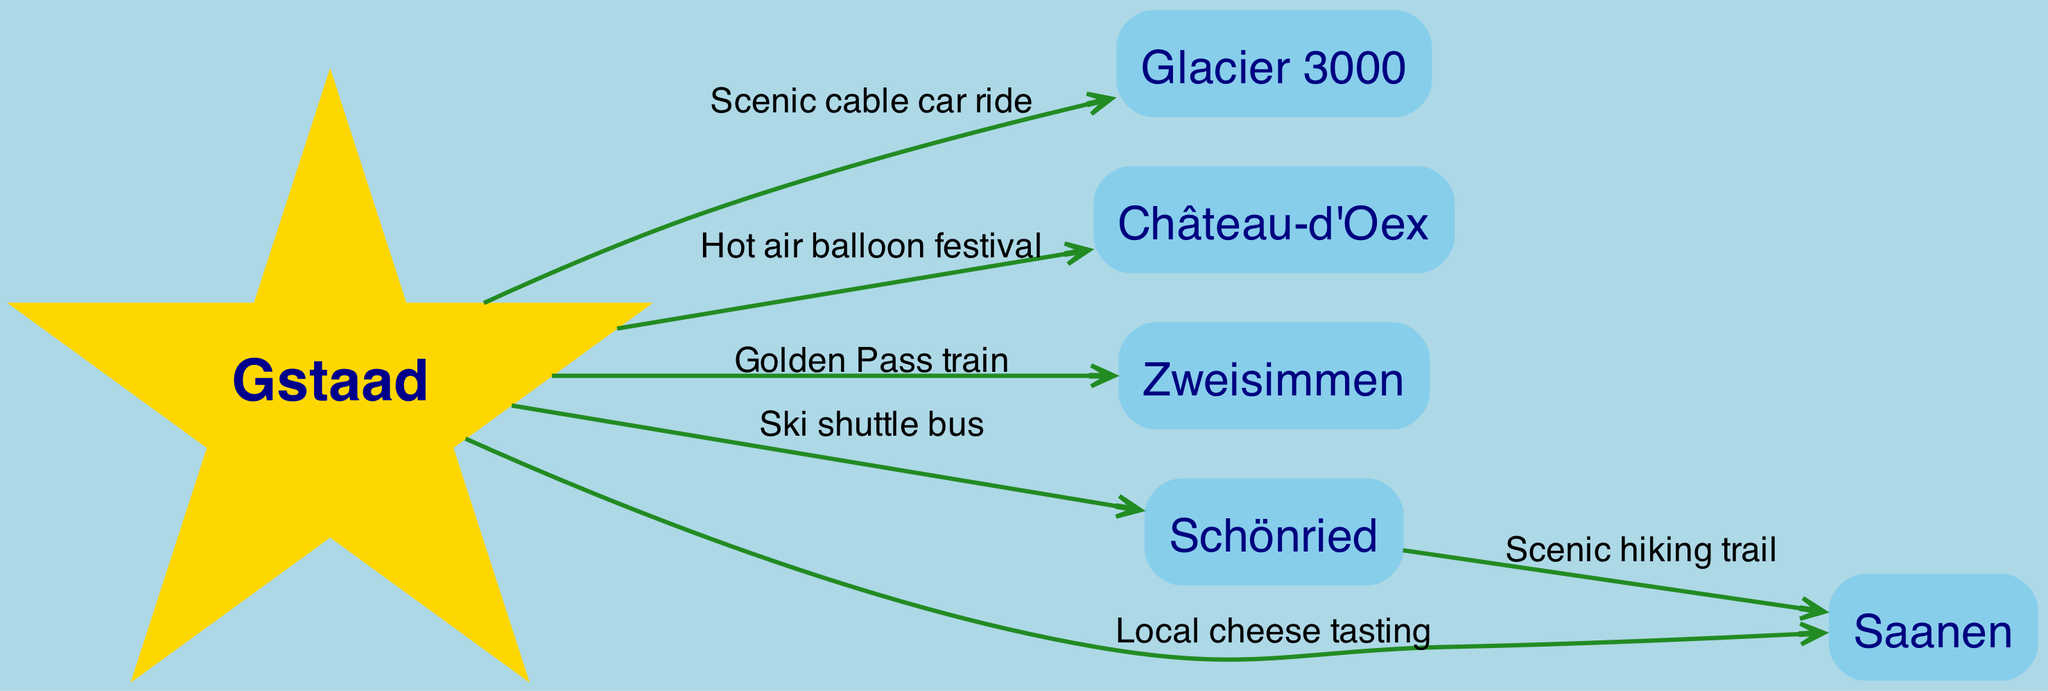What's the starting point of the tourism flow? The starting point of the tourism flow is represented by the node "Gstaad." This can be identified by looking at the diagram and noticing that it is the only node shaped like a star and positioned at the beginning.
Answer: Gstaad How many nodes are in the diagram? To find the total number of nodes, count them directly from the nodes list provided: Gstaad, Glacier 3000, Château-d'Oex, Zweisimmen, Schönried, and Saanen. There are six nodes in total.
Answer: 6 Which attraction is connected to Gstaad by a ski shuttle bus? According to the diagram, the edge labeled "Ski shuttle bus" connects Gstaad to "Schönried." This indicates that tourists can travel from Gstaad to Schönried by using this transportation option.
Answer: Schönried What event connects Gstaad to Château-d'Oex? The edge labeled "Hot air balloon festival" connects Gstaad to Château-d'Oex. This indicates that the event is a significant draw for tourists traveling from Gstaad to that location.
Answer: Hot air balloon festival What is the intermediate destination between Schönried and Saanen? In the diagram, the edge labeled "Scenic hiking trail" shows a connection from Schönried to Saanen. This means that tourists can hike from Schönried to Saanen along this scenic trail, indicating Saanen is the intermediate destination here.
Answer: Saanen Which transportation method is used to reach Glacier 3000 from Gstaad? The edge connecting Gstaad to Glacier 3000 is labeled "Scenic cable car ride." This indicates that the method of transportation to reach Glacier 3000 is via a scenic cable car.
Answer: Scenic cable car ride How many edges are shown in the diagram? To find the total number of edges, count the connections listed: there are five edges connecting various nodes. Each edge represents a distinct flow of tourism between locations.
Answer: 5 Which two nodes are directly connected by the scenic hiking trail? The edge labeled "Scenic hiking trail" illustrates a direct connection between the nodes Schönried and Saanen. This informs travelers of the hiking option between these two locations.
Answer: Schönried and Saanen 